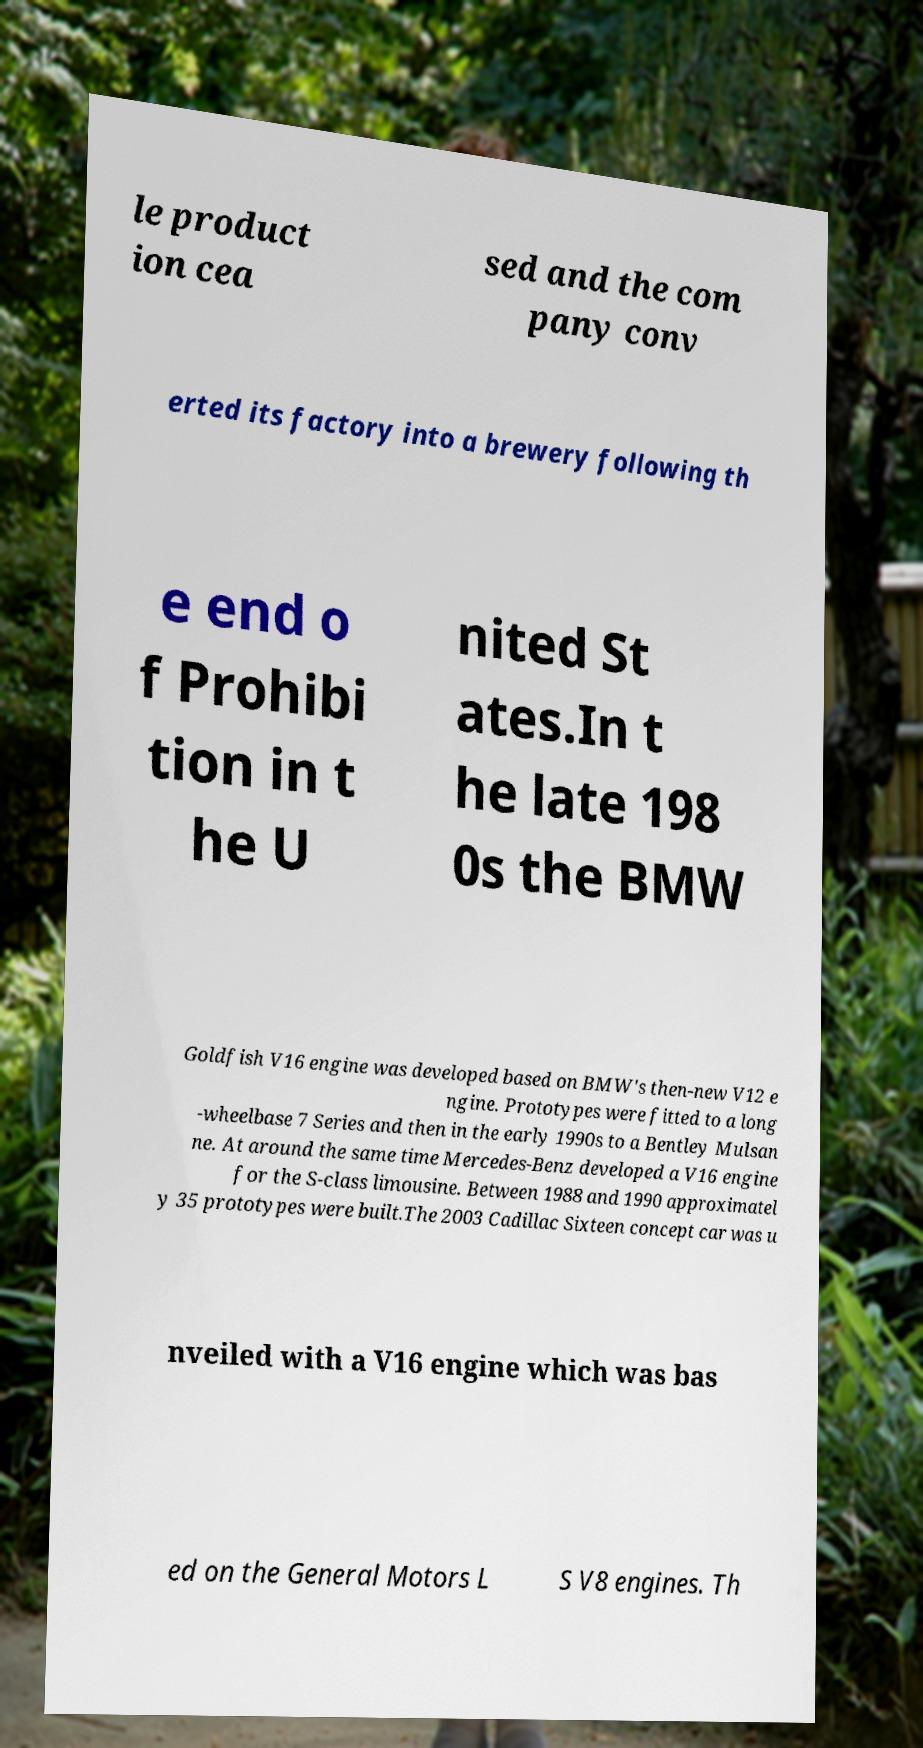What messages or text are displayed in this image? I need them in a readable, typed format. le product ion cea sed and the com pany conv erted its factory into a brewery following th e end o f Prohibi tion in t he U nited St ates.In t he late 198 0s the BMW Goldfish V16 engine was developed based on BMW's then-new V12 e ngine. Prototypes were fitted to a long -wheelbase 7 Series and then in the early 1990s to a Bentley Mulsan ne. At around the same time Mercedes-Benz developed a V16 engine for the S-class limousine. Between 1988 and 1990 approximatel y 35 prototypes were built.The 2003 Cadillac Sixteen concept car was u nveiled with a V16 engine which was bas ed on the General Motors L S V8 engines. Th 